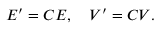Convert formula to latex. <formula><loc_0><loc_0><loc_500><loc_500>E ^ { \prime } = C E , \quad V ^ { \prime } = C V .</formula> 